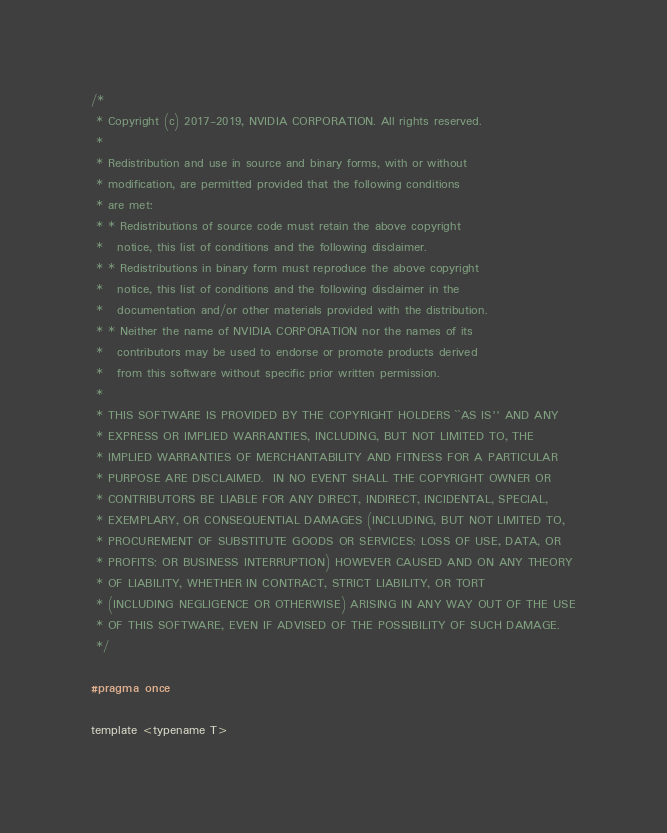<code> <loc_0><loc_0><loc_500><loc_500><_Cuda_>/*
 * Copyright (c) 2017-2019, NVIDIA CORPORATION. All rights reserved.
 *
 * Redistribution and use in source and binary forms, with or without
 * modification, are permitted provided that the following conditions
 * are met:
 * * Redistributions of source code must retain the above copyright
 *   notice, this list of conditions and the following disclaimer.
 * * Redistributions in binary form must reproduce the above copyright
 *   notice, this list of conditions and the following disclaimer in the
 *   documentation and/or other materials provided with the distribution.
 * * Neither the name of NVIDIA CORPORATION nor the names of its
 *   contributors may be used to endorse or promote products derived
 *   from this software without specific prior written permission.
 *
 * THIS SOFTWARE IS PROVIDED BY THE COPYRIGHT HOLDERS ``AS IS'' AND ANY
 * EXPRESS OR IMPLIED WARRANTIES, INCLUDING, BUT NOT LIMITED TO, THE
 * IMPLIED WARRANTIES OF MERCHANTABILITY AND FITNESS FOR A PARTICULAR
 * PURPOSE ARE DISCLAIMED.  IN NO EVENT SHALL THE COPYRIGHT OWNER OR
 * CONTRIBUTORS BE LIABLE FOR ANY DIRECT, INDIRECT, INCIDENTAL, SPECIAL,
 * EXEMPLARY, OR CONSEQUENTIAL DAMAGES (INCLUDING, BUT NOT LIMITED TO,
 * PROCUREMENT OF SUBSTITUTE GOODS OR SERVICES; LOSS OF USE, DATA, OR
 * PROFITS; OR BUSINESS INTERRUPTION) HOWEVER CAUSED AND ON ANY THEORY
 * OF LIABILITY, WHETHER IN CONTRACT, STRICT LIABILITY, OR TORT
 * (INCLUDING NEGLIGENCE OR OTHERWISE) ARISING IN ANY WAY OUT OF THE USE
 * OF THIS SOFTWARE, EVEN IF ADVISED OF THE POSSIBILITY OF SUCH DAMAGE.
 */

#pragma once

template <typename T></code> 